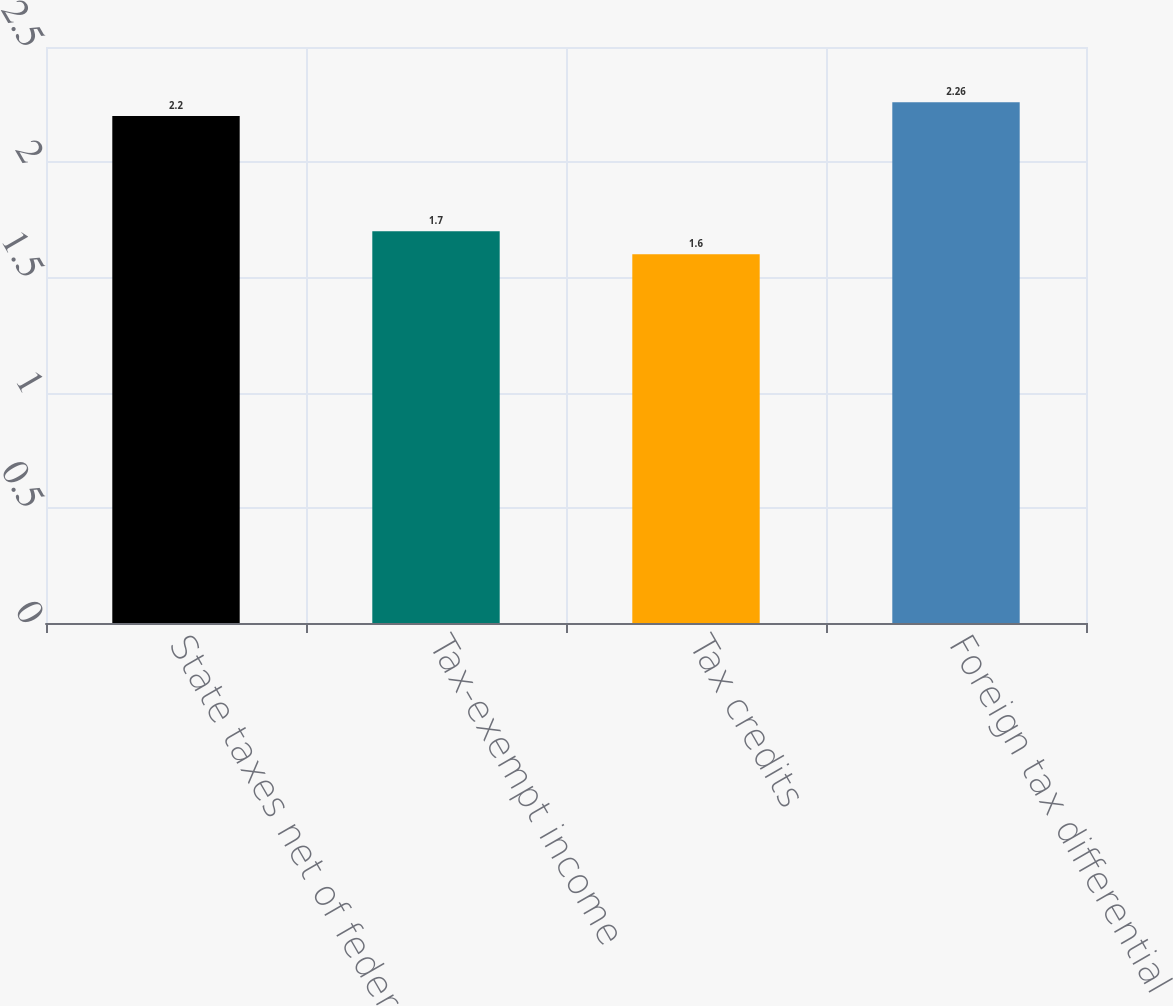<chart> <loc_0><loc_0><loc_500><loc_500><bar_chart><fcel>State taxes net of federal<fcel>Tax-exempt income<fcel>Tax credits<fcel>Foreign tax differential<nl><fcel>2.2<fcel>1.7<fcel>1.6<fcel>2.26<nl></chart> 